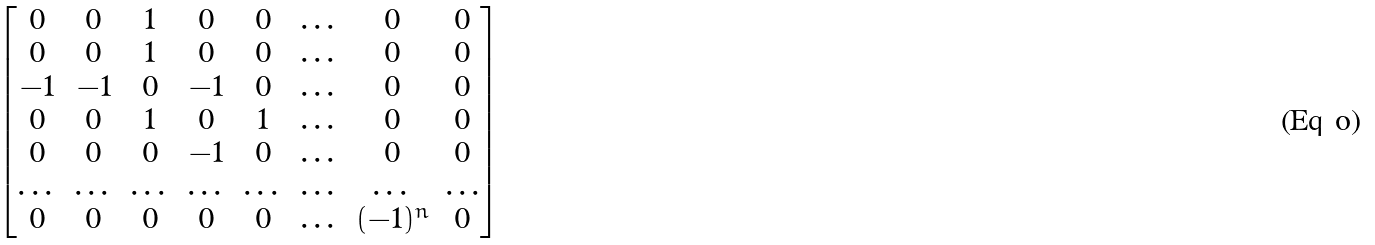Convert formula to latex. <formula><loc_0><loc_0><loc_500><loc_500>\begin{bmatrix} 0 & 0 & 1 & 0 & 0 & \dots & 0 & 0 \\ 0 & 0 & 1 & 0 & 0 & \dots & 0 & 0 \\ - 1 & - 1 & 0 & - 1 & 0 & \dots & 0 & 0 \\ 0 & 0 & 1 & 0 & 1 & \dots & 0 & 0 \\ 0 & 0 & 0 & - 1 & 0 & \dots & 0 & 0 \\ \dots & \dots & \dots & \dots & \dots & \dots & \dots & \dots \\ 0 & 0 & 0 & 0 & 0 & \dots & ( - 1 ) ^ { n } & 0 \\ \end{bmatrix}</formula> 